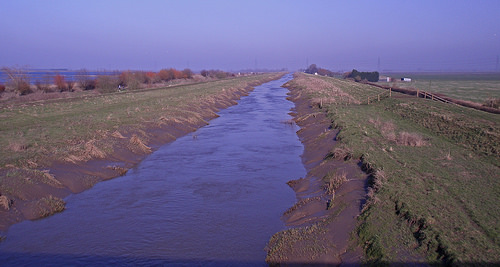<image>
Is there a river next to the bank? Yes. The river is positioned adjacent to the bank, located nearby in the same general area. 